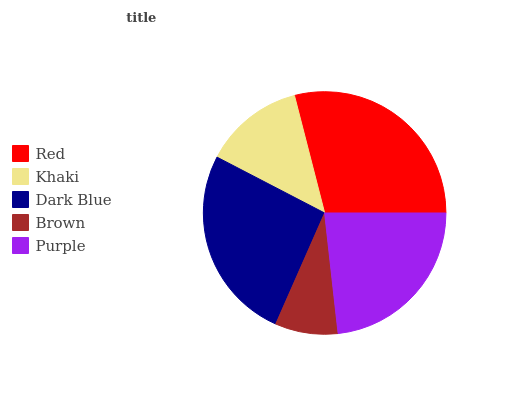Is Brown the minimum?
Answer yes or no. Yes. Is Red the maximum?
Answer yes or no. Yes. Is Khaki the minimum?
Answer yes or no. No. Is Khaki the maximum?
Answer yes or no. No. Is Red greater than Khaki?
Answer yes or no. Yes. Is Khaki less than Red?
Answer yes or no. Yes. Is Khaki greater than Red?
Answer yes or no. No. Is Red less than Khaki?
Answer yes or no. No. Is Purple the high median?
Answer yes or no. Yes. Is Purple the low median?
Answer yes or no. Yes. Is Khaki the high median?
Answer yes or no. No. Is Dark Blue the low median?
Answer yes or no. No. 